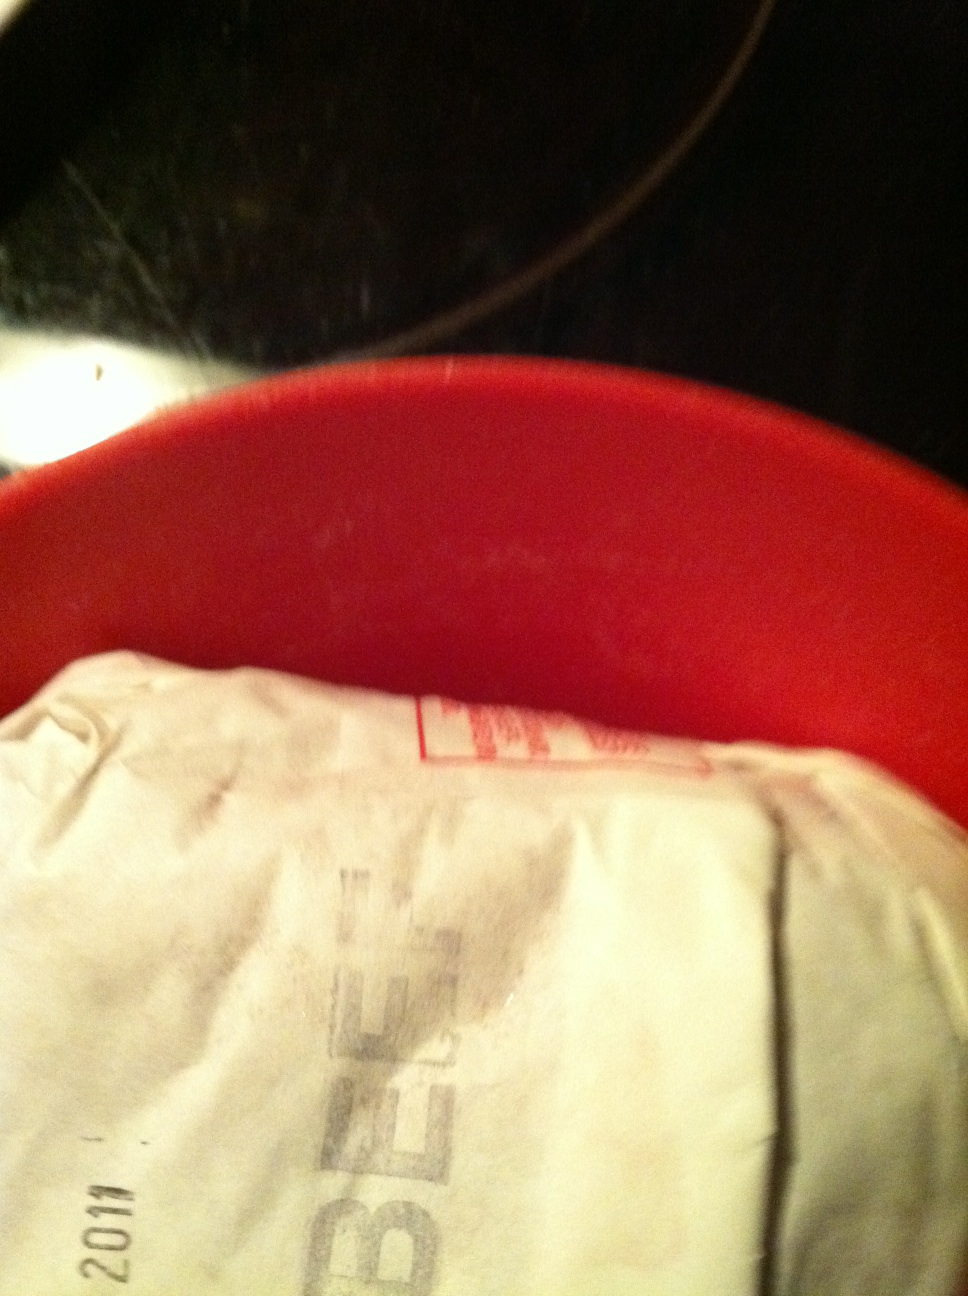Can you tell me what type of meat this is, or if there's a label there? The type of meat shown in the image is beef. The package appears to have a label indicating this with the word 'BEEF' printed on it. However, other details on the label are not clearly visible. 